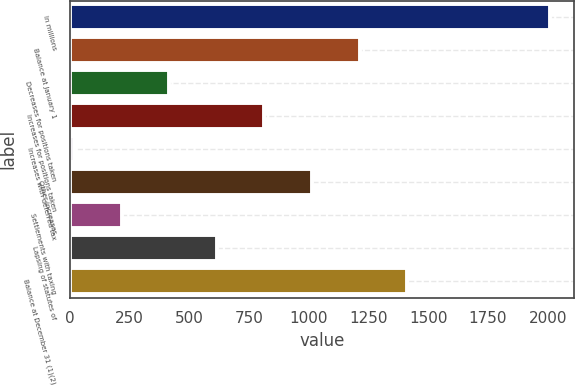Convert chart. <chart><loc_0><loc_0><loc_500><loc_500><bar_chart><fcel>In millions<fcel>Balance at January 1<fcel>Decreases for positions taken<fcel>Increases for positions taken<fcel>Increases with deferred tax<fcel>Other increases<fcel>Settlements with taxing<fcel>Lapsing of statutes of<fcel>Balance at December 31 (1)(2)<nl><fcel>2010<fcel>1212.52<fcel>415.04<fcel>813.78<fcel>16.3<fcel>1013.15<fcel>215.67<fcel>614.41<fcel>1411.89<nl></chart> 